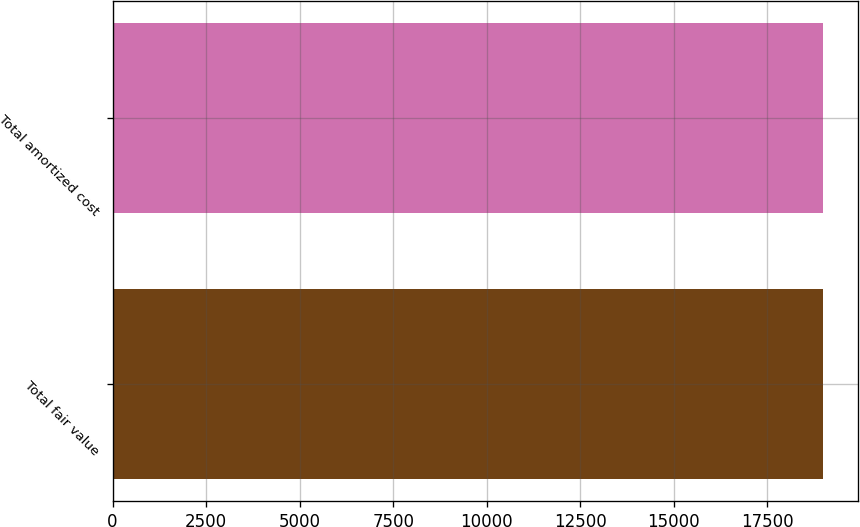<chart> <loc_0><loc_0><loc_500><loc_500><bar_chart><fcel>Total fair value<fcel>Total amortized cost<nl><fcel>18972<fcel>18981<nl></chart> 